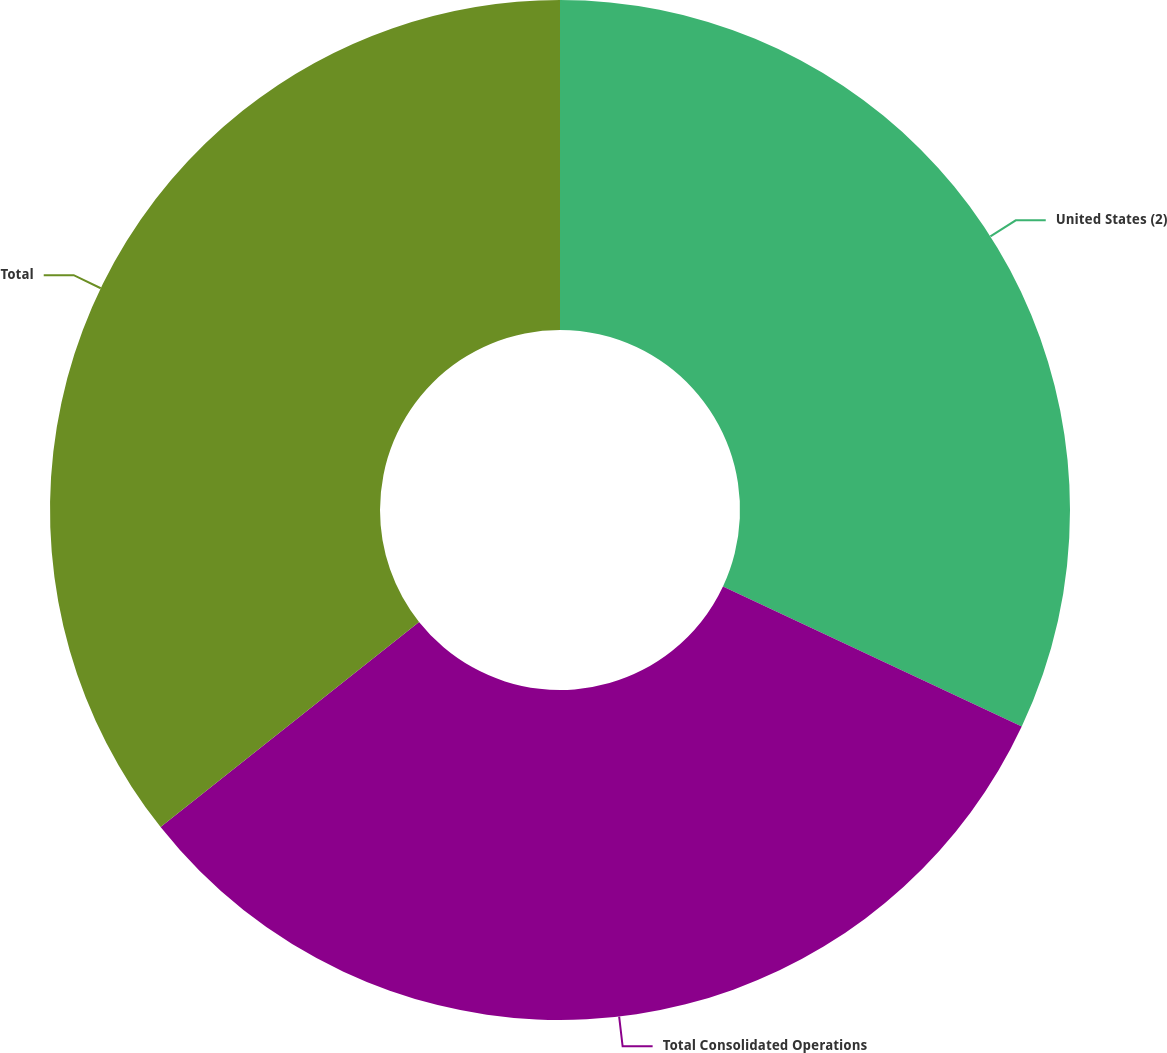Convert chart. <chart><loc_0><loc_0><loc_500><loc_500><pie_chart><fcel>United States (2)<fcel>Total Consolidated Operations<fcel>Total<nl><fcel>31.98%<fcel>32.34%<fcel>35.68%<nl></chart> 